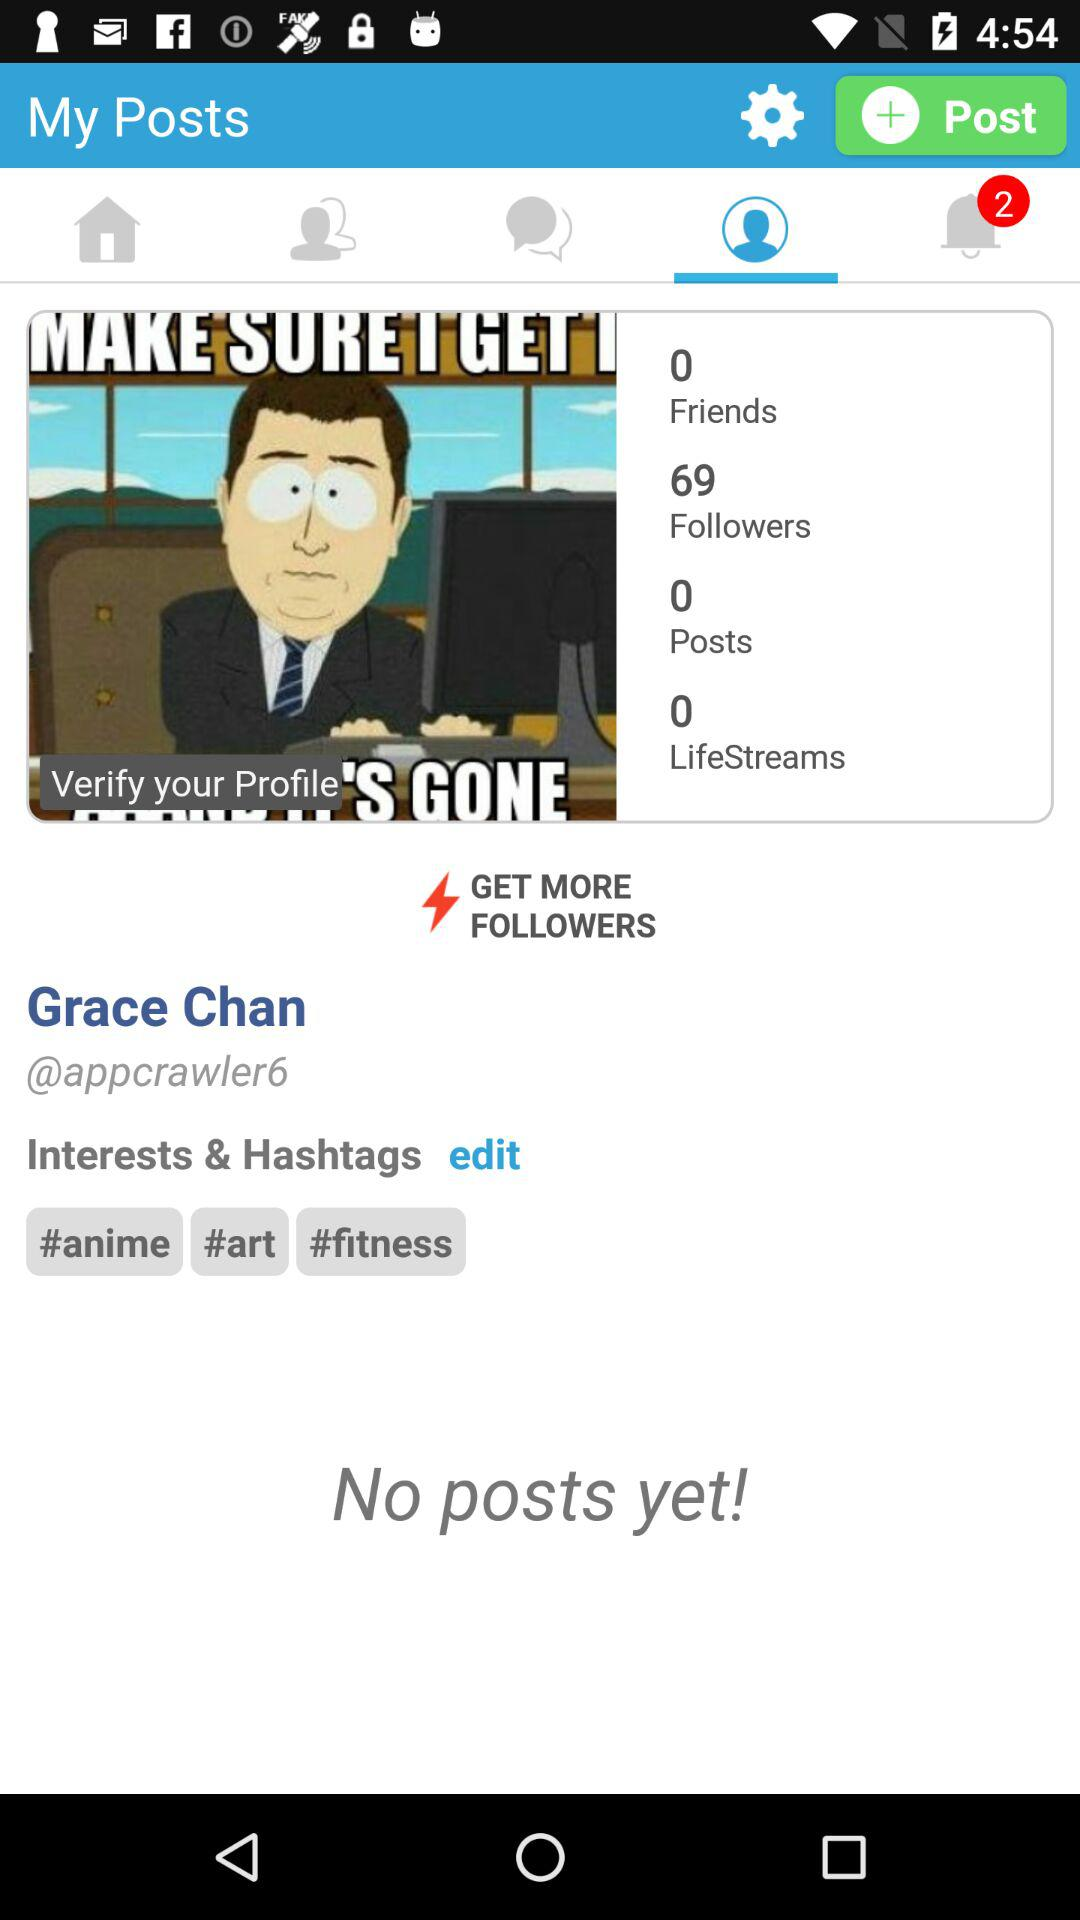How many posts are there? There are 0 posts. 